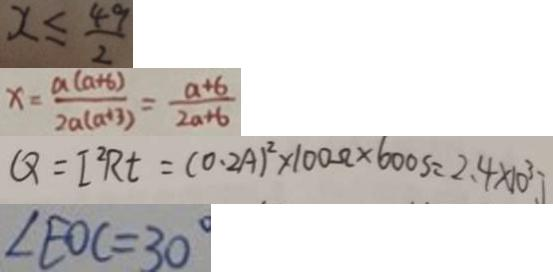<formula> <loc_0><loc_0><loc_500><loc_500>x \leq \frac { 4 9 } { 2 } 
 x = \frac { a ( a + b ) } { 2 a ( a + 3 ) } = \frac { a + 6 } { 2 a + 6 } 
 Q = I ^ { 2 } R t = ( 0 . 2 A ) ^ { 2 } \times 1 0 0 \Omega \times 6 0 0 S = 2 . 4 \times 1 0 ^ { 3 } J 
 \angle E O C = 3 0 ^ { \circ }</formula> 